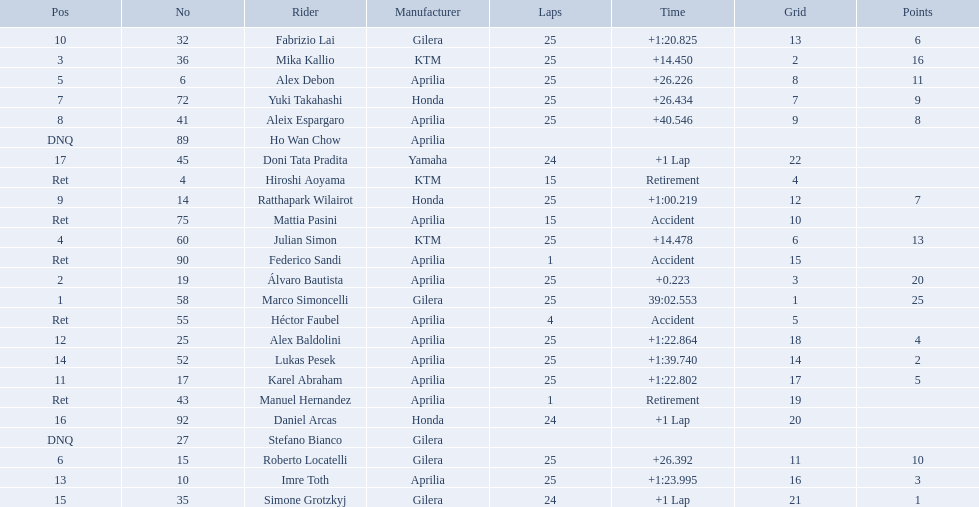What player number is marked #1 for the australian motorcycle grand prix? 58. Who is the rider that represents the #58 in the australian motorcycle grand prix? Marco Simoncelli. 